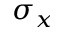Convert formula to latex. <formula><loc_0><loc_0><loc_500><loc_500>\sigma _ { x }</formula> 